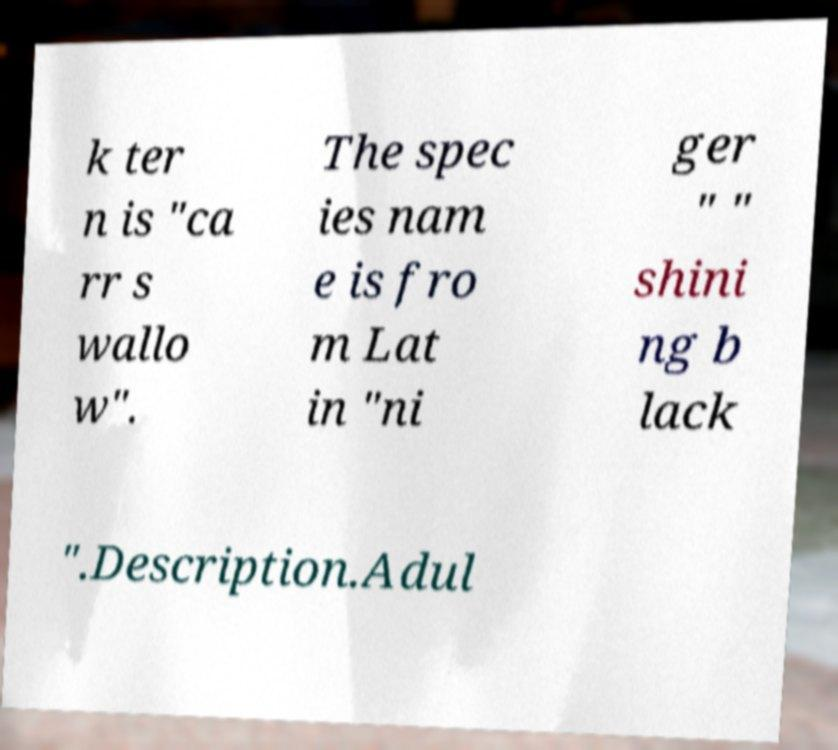For documentation purposes, I need the text within this image transcribed. Could you provide that? k ter n is "ca rr s wallo w". The spec ies nam e is fro m Lat in "ni ger " " shini ng b lack ".Description.Adul 